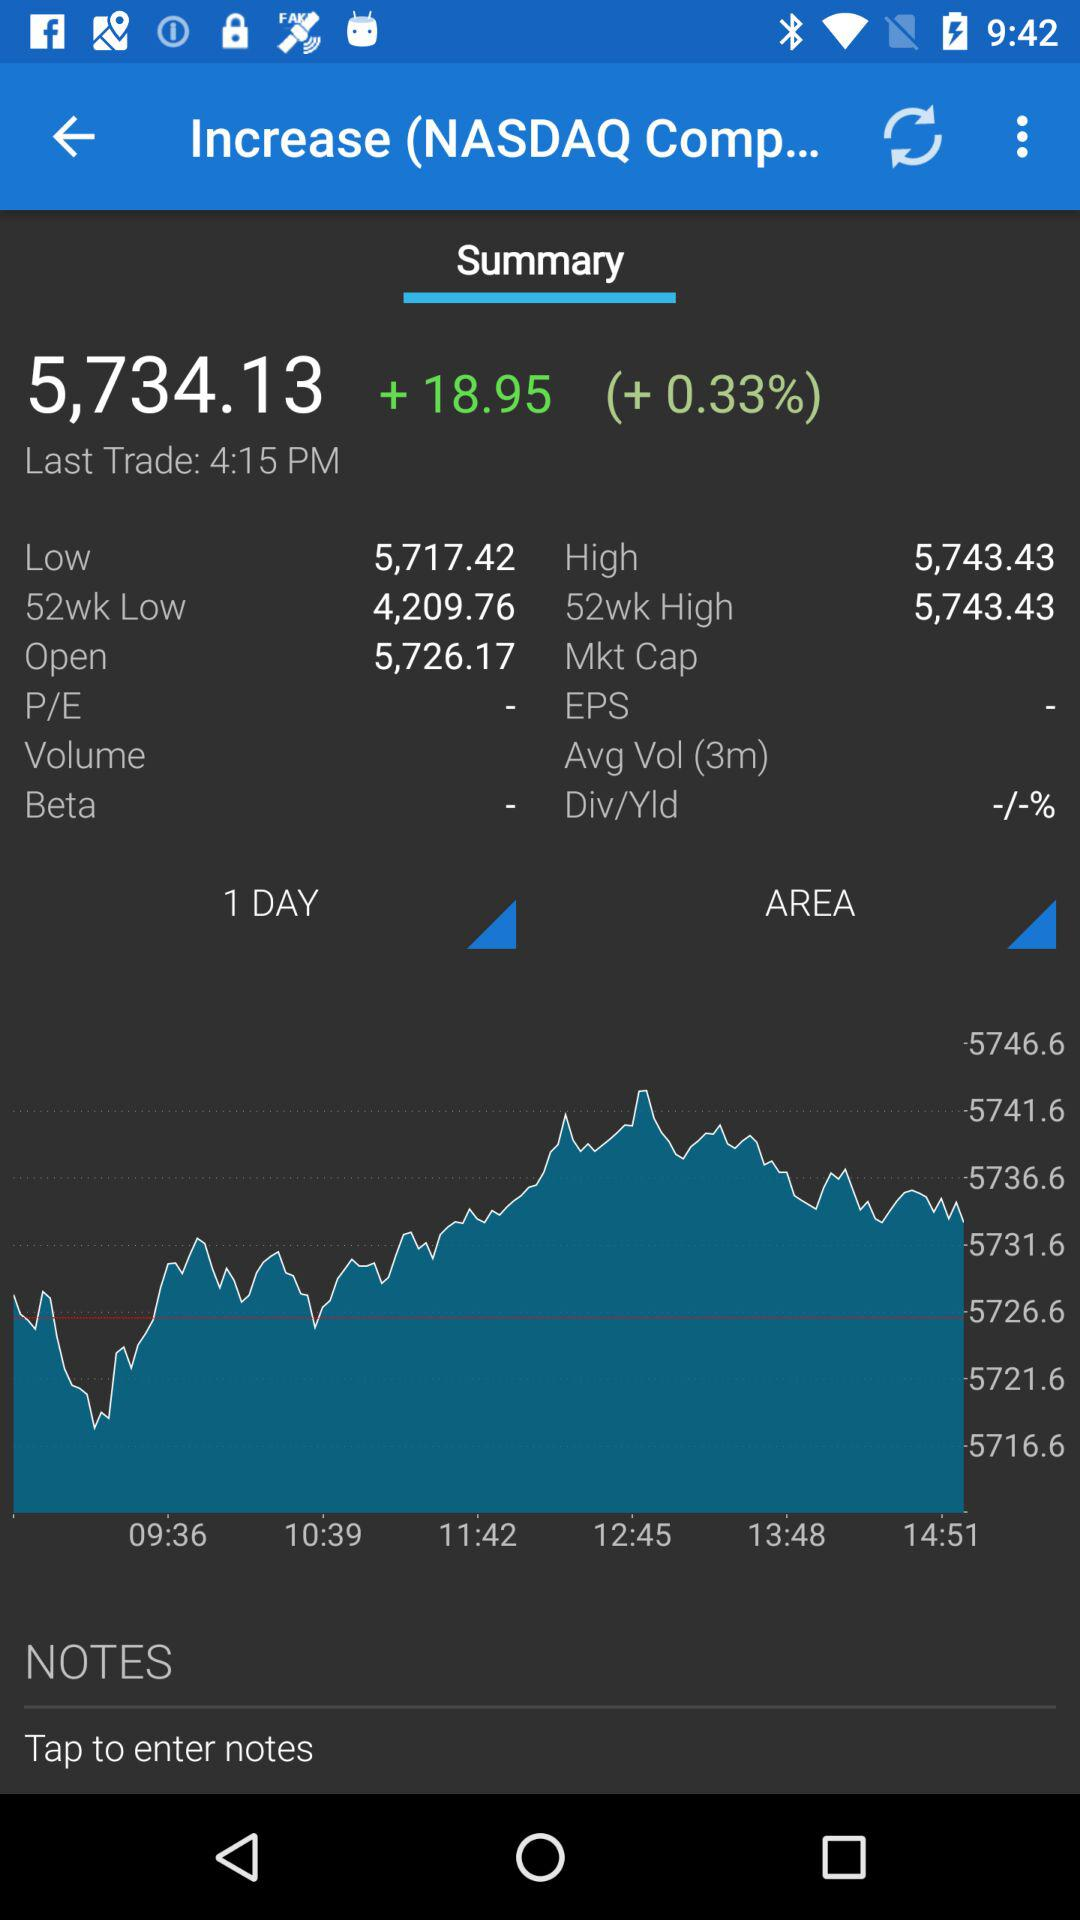What's the opening price? The opening price is 5,726.17. 